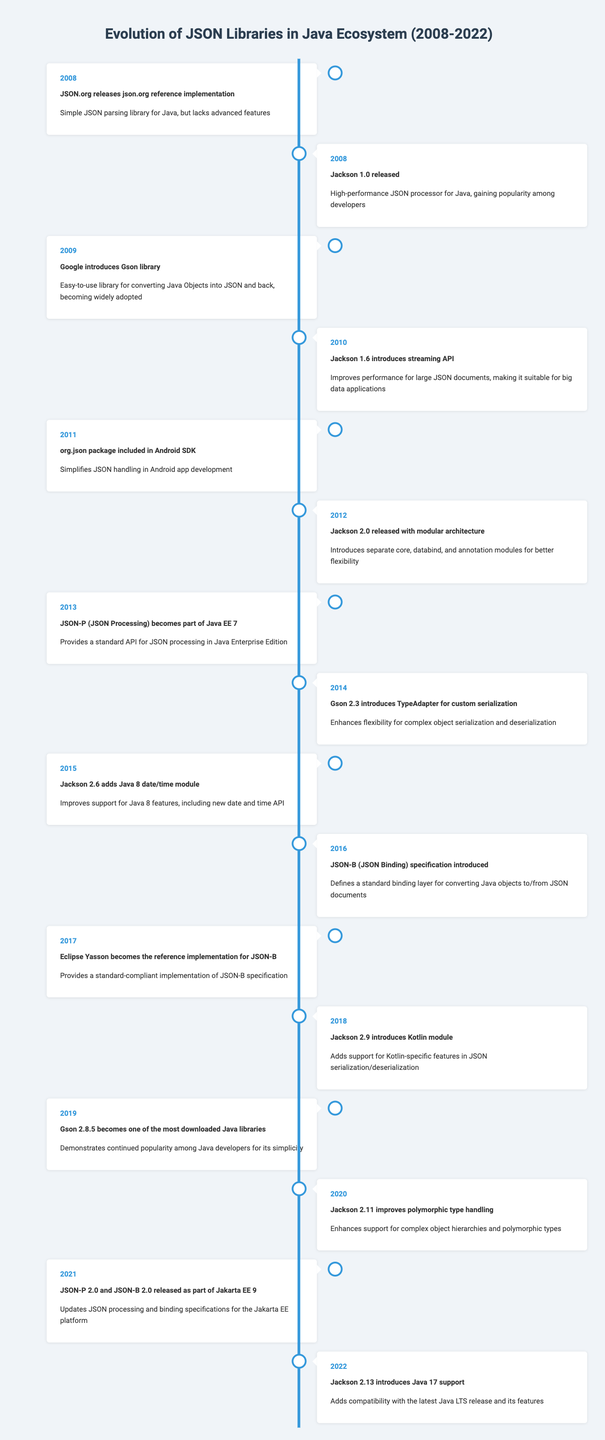What significant event in JSON library evolution occurred in 2010? In 2010, Jackson 1.6 introduced a streaming API which improves performance for large JSON documents, making it suitable for big data applications.
Answer: Jackson 1.6 introduces streaming API How many years after Gson was introduced did Jackson 2.0 get released? Gson was introduced in 2009, and Jackson 2.0 was released in 2012. The difference is 2012 - 2009 = 3 years.
Answer: 3 years Was JSON-P integrated into Java EE before Jackson 2.6 added the Java 8 date/time module? JSON-P became part of Java EE 7 in 2013, while Jackson 2.6 added Java 8 date/time support in 2015. Since 2013 is before 2015, the fact is true.
Answer: Yes What was the main feature introduced in Gson 2.3 in 2014? Gson 2.3 introduced a TypeAdapter for custom serialization, enhancing flexibility for complex object serialization and deserialization.
Answer: TypeAdapter for custom serialization How many events reference improvements in compatibility with the latest Java versions after 2015? Two events mention compatibility with newer Java versions; Jackson 2.6 adds Java 8 support, and Jackson 2.13 introduces support for Java 17. So, the count is 2.
Answer: 2 events Which JSON library became the reference implementation for JSON-B in 2017? In 2017, Eclipse Yasson became the reference implementation for JSON-B, providing a standard-compliant implementation of the specification.
Answer: Eclipse Yasson Was there an introduction of a library specific to Kotlin before 2019? Jackson 2.9 introduced a Kotlin module in 2018, meaning there was no Kotlin-specific library before that. So, the answer is true.
Answer: No What common trend can be deduced about the release of updates to Jackson and Gson? Both libraries received updates consistently over the years, with significant improvements mostly addressing compatibility with newer Java features and enhancements for complex serialization processes. This suggests a competitive evolution in response to developers' needs.
Answer: Continuous updates for enhancement and compatibility 